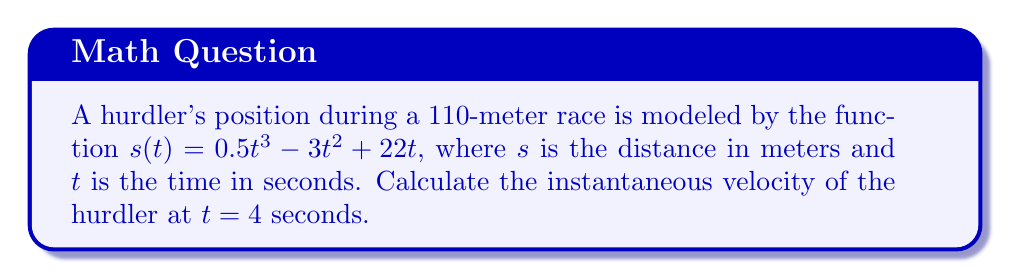Teach me how to tackle this problem. To find the instantaneous velocity at a specific point, we need to calculate the derivative of the position function and evaluate it at the given time.

Step 1: Find the derivative of the position function $s(t)$.
$$\frac{d}{dt}s(t) = \frac{d}{dt}(0.5t^3 - 3t^2 + 22t)$$
$$v(t) = 1.5t^2 - 6t + 22$$

Step 2: The function $v(t)$ represents the velocity at any given time $t$.

Step 3: Evaluate $v(t)$ at $t = 4$ seconds.
$$v(4) = 1.5(4)^2 - 6(4) + 22$$
$$v(4) = 1.5(16) - 24 + 22$$
$$v(4) = 24 - 24 + 22 = 22$$

Therefore, the instantaneous velocity of the hurdler at $t = 4$ seconds is 22 meters per second.
Answer: 22 m/s 